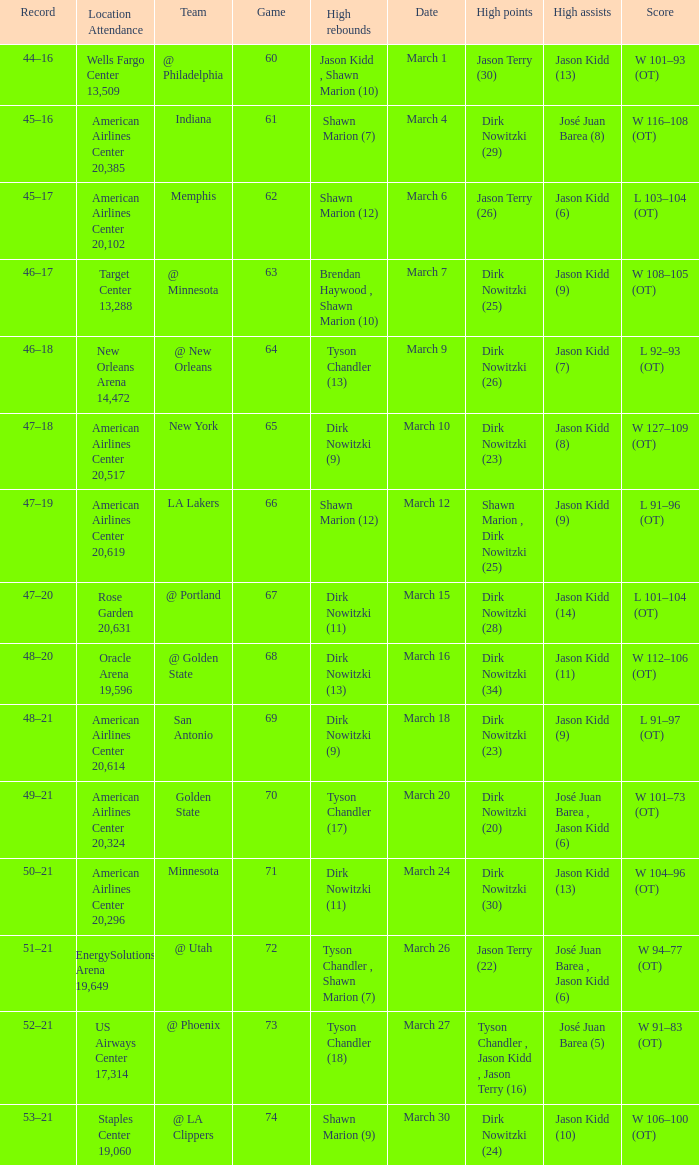Name the high assists for  l 103–104 (ot) Jason Kidd (6). 